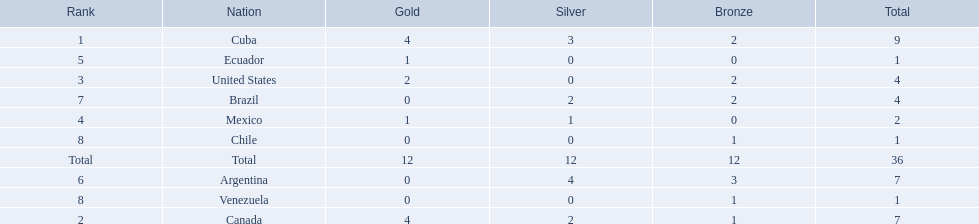Which countries have won gold medals? Cuba, Canada, United States, Mexico, Ecuador. Of these countries, which ones have never won silver or bronze medals? United States, Ecuador. Of the two nations listed previously, which one has only won a gold medal? Ecuador. 